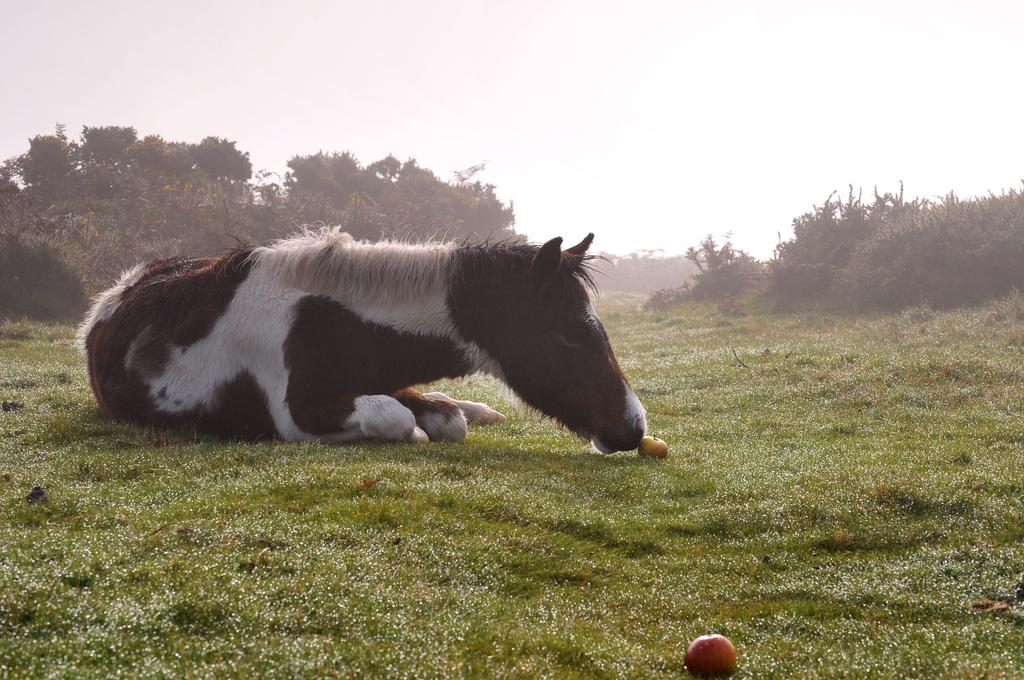What type of animal is in the image? There is an animal in the image, but the specific type cannot be determined from the provided facts. Where is the animal located in the image? The animal is on the grass in the image. What other objects can be seen in the image? There are fruits and trees visible in the image. What type of bean is growing on the animal's body in the image? There is no bean or indication of a bean growing on the animal's body in the image. How many bricks are stacked on the animal's back in the image? There are no bricks present in the image, let alone stacked on the animal's back. 